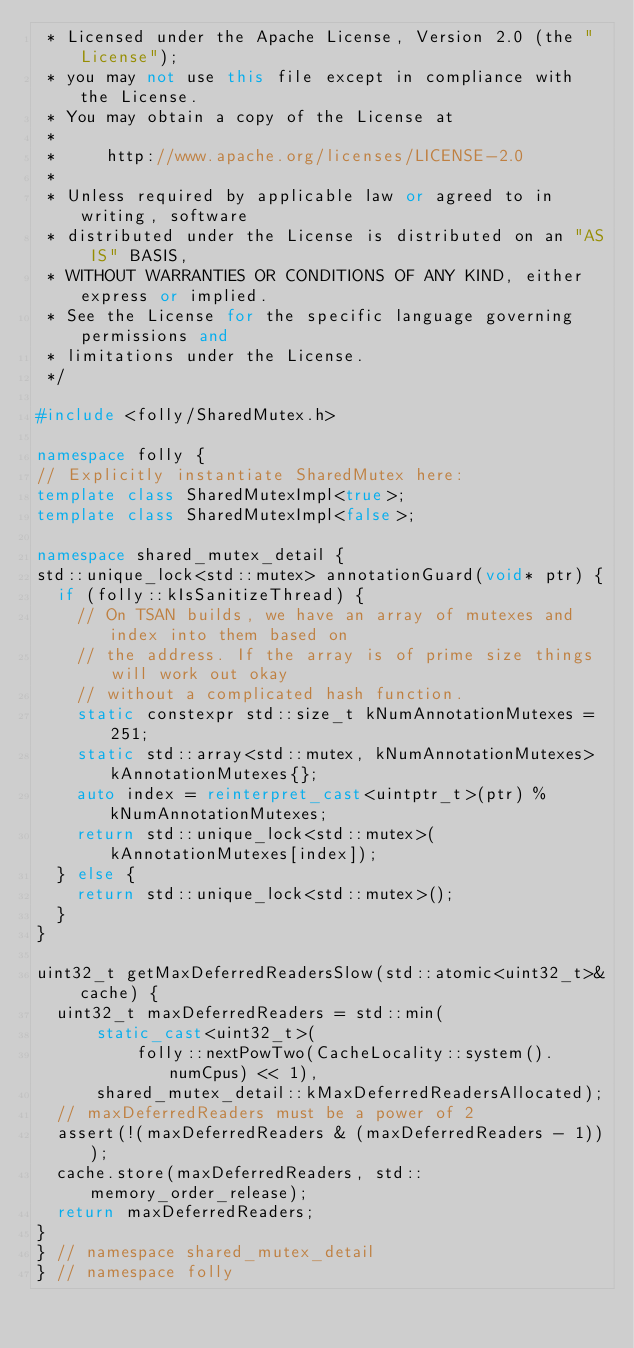Convert code to text. <code><loc_0><loc_0><loc_500><loc_500><_C++_> * Licensed under the Apache License, Version 2.0 (the "License");
 * you may not use this file except in compliance with the License.
 * You may obtain a copy of the License at
 *
 *     http://www.apache.org/licenses/LICENSE-2.0
 *
 * Unless required by applicable law or agreed to in writing, software
 * distributed under the License is distributed on an "AS IS" BASIS,
 * WITHOUT WARRANTIES OR CONDITIONS OF ANY KIND, either express or implied.
 * See the License for the specific language governing permissions and
 * limitations under the License.
 */

#include <folly/SharedMutex.h>

namespace folly {
// Explicitly instantiate SharedMutex here:
template class SharedMutexImpl<true>;
template class SharedMutexImpl<false>;

namespace shared_mutex_detail {
std::unique_lock<std::mutex> annotationGuard(void* ptr) {
  if (folly::kIsSanitizeThread) {
    // On TSAN builds, we have an array of mutexes and index into them based on
    // the address. If the array is of prime size things will work out okay
    // without a complicated hash function.
    static constexpr std::size_t kNumAnnotationMutexes = 251;
    static std::array<std::mutex, kNumAnnotationMutexes> kAnnotationMutexes{};
    auto index = reinterpret_cast<uintptr_t>(ptr) % kNumAnnotationMutexes;
    return std::unique_lock<std::mutex>(kAnnotationMutexes[index]);
  } else {
    return std::unique_lock<std::mutex>();
  }
}

uint32_t getMaxDeferredReadersSlow(std::atomic<uint32_t>& cache) {
  uint32_t maxDeferredReaders = std::min(
      static_cast<uint32_t>(
          folly::nextPowTwo(CacheLocality::system().numCpus) << 1),
      shared_mutex_detail::kMaxDeferredReadersAllocated);
  // maxDeferredReaders must be a power of 2
  assert(!(maxDeferredReaders & (maxDeferredReaders - 1)));
  cache.store(maxDeferredReaders, std::memory_order_release);
  return maxDeferredReaders;
}
} // namespace shared_mutex_detail
} // namespace folly
</code> 